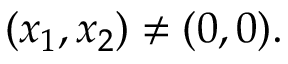Convert formula to latex. <formula><loc_0><loc_0><loc_500><loc_500>( x _ { 1 } , x _ { 2 } ) \neq ( 0 , 0 ) .</formula> 